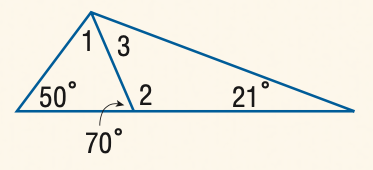Question: Find the measure of \angle 2.
Choices:
A. 110
B. 120
C. 130
D. 140
Answer with the letter. Answer: A Question: Find the measure of \angle 3.
Choices:
A. 49
B. 50
C. 60
D. 70
Answer with the letter. Answer: A 